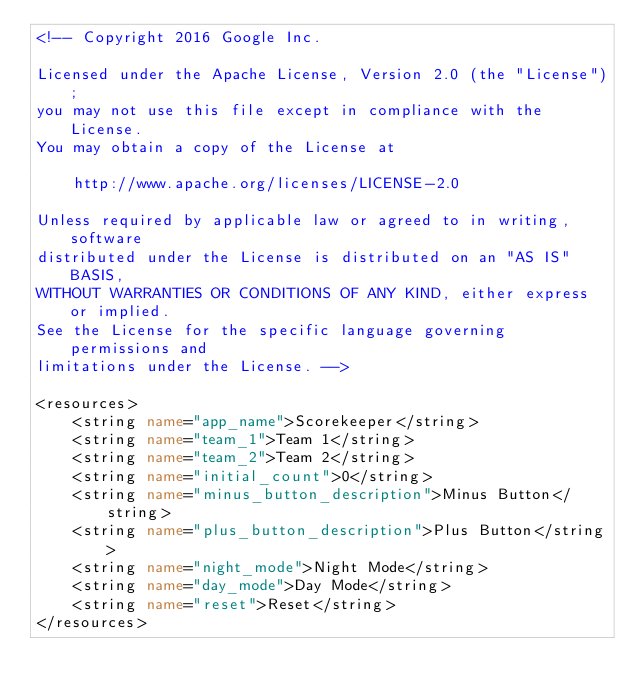<code> <loc_0><loc_0><loc_500><loc_500><_XML_><!-- Copyright 2016 Google Inc.

Licensed under the Apache License, Version 2.0 (the "License");
you may not use this file except in compliance with the License.
You may obtain a copy of the License at

    http://www.apache.org/licenses/LICENSE-2.0

Unless required by applicable law or agreed to in writing, software
distributed under the License is distributed on an "AS IS" BASIS,
WITHOUT WARRANTIES OR CONDITIONS OF ANY KIND, either express or implied.
See the License for the specific language governing permissions and
limitations under the License. -->

<resources>
    <string name="app_name">Scorekeeper</string>
    <string name="team_1">Team 1</string>
    <string name="team_2">Team 2</string>
    <string name="initial_count">0</string>
    <string name="minus_button_description">Minus Button</string>
    <string name="plus_button_description">Plus Button</string>
    <string name="night_mode">Night Mode</string>
    <string name="day_mode">Day Mode</string>
    <string name="reset">Reset</string>
</resources></code> 